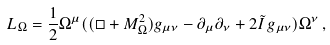Convert formula to latex. <formula><loc_0><loc_0><loc_500><loc_500>L _ { \Omega } = \frac { 1 } { 2 } \Omega ^ { \mu } ( ( \Box + M _ { \Omega } ^ { 2 } ) g _ { \mu \nu } - \partial _ { \mu } \partial _ { \nu } + 2 \tilde { I } \, g _ { \mu \nu } ) \Omega ^ { \nu } \, ,</formula> 